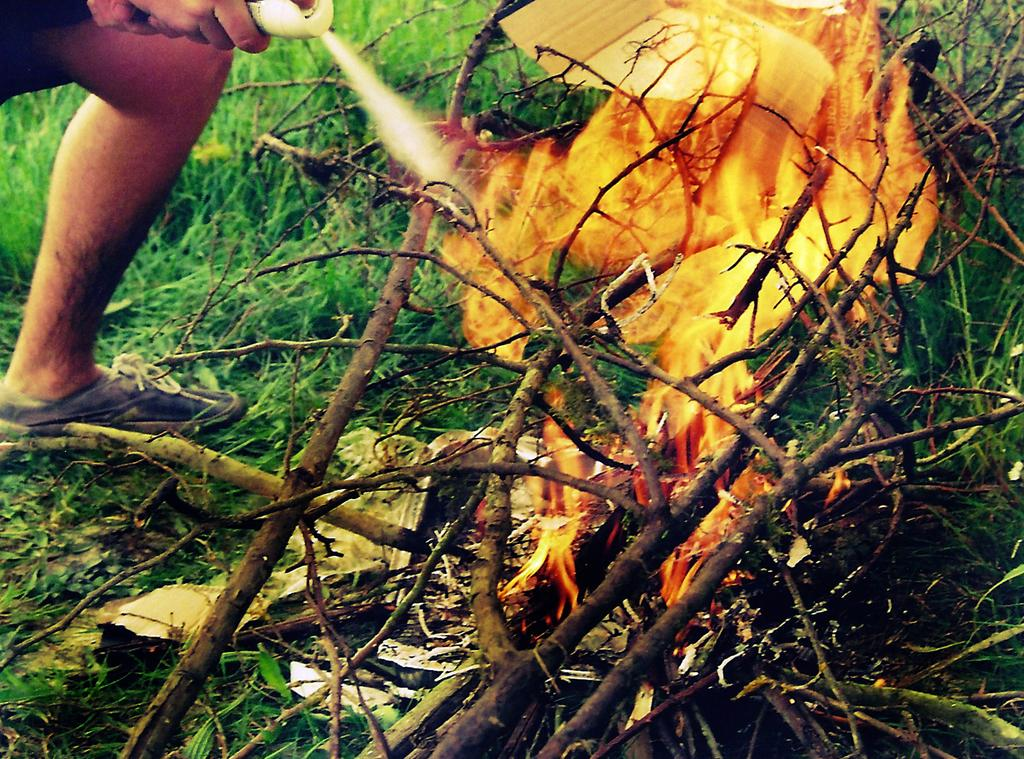What is the main feature in the center of the image? There is fire in the center of the image. What is being burned in the fire? There are sticks in the fire. What type of natural environment is visible in the background of the image? Grass is visible in the background of the image. What is the person in the top left corner of the image holding? The person is holding a bottle in the top left corner of the image. Can you see a playground in the image? No, there is no playground present in the image. What type of bread is being toasted in the fire? There is no bread visible in the image; only sticks are being burned in the fire. 